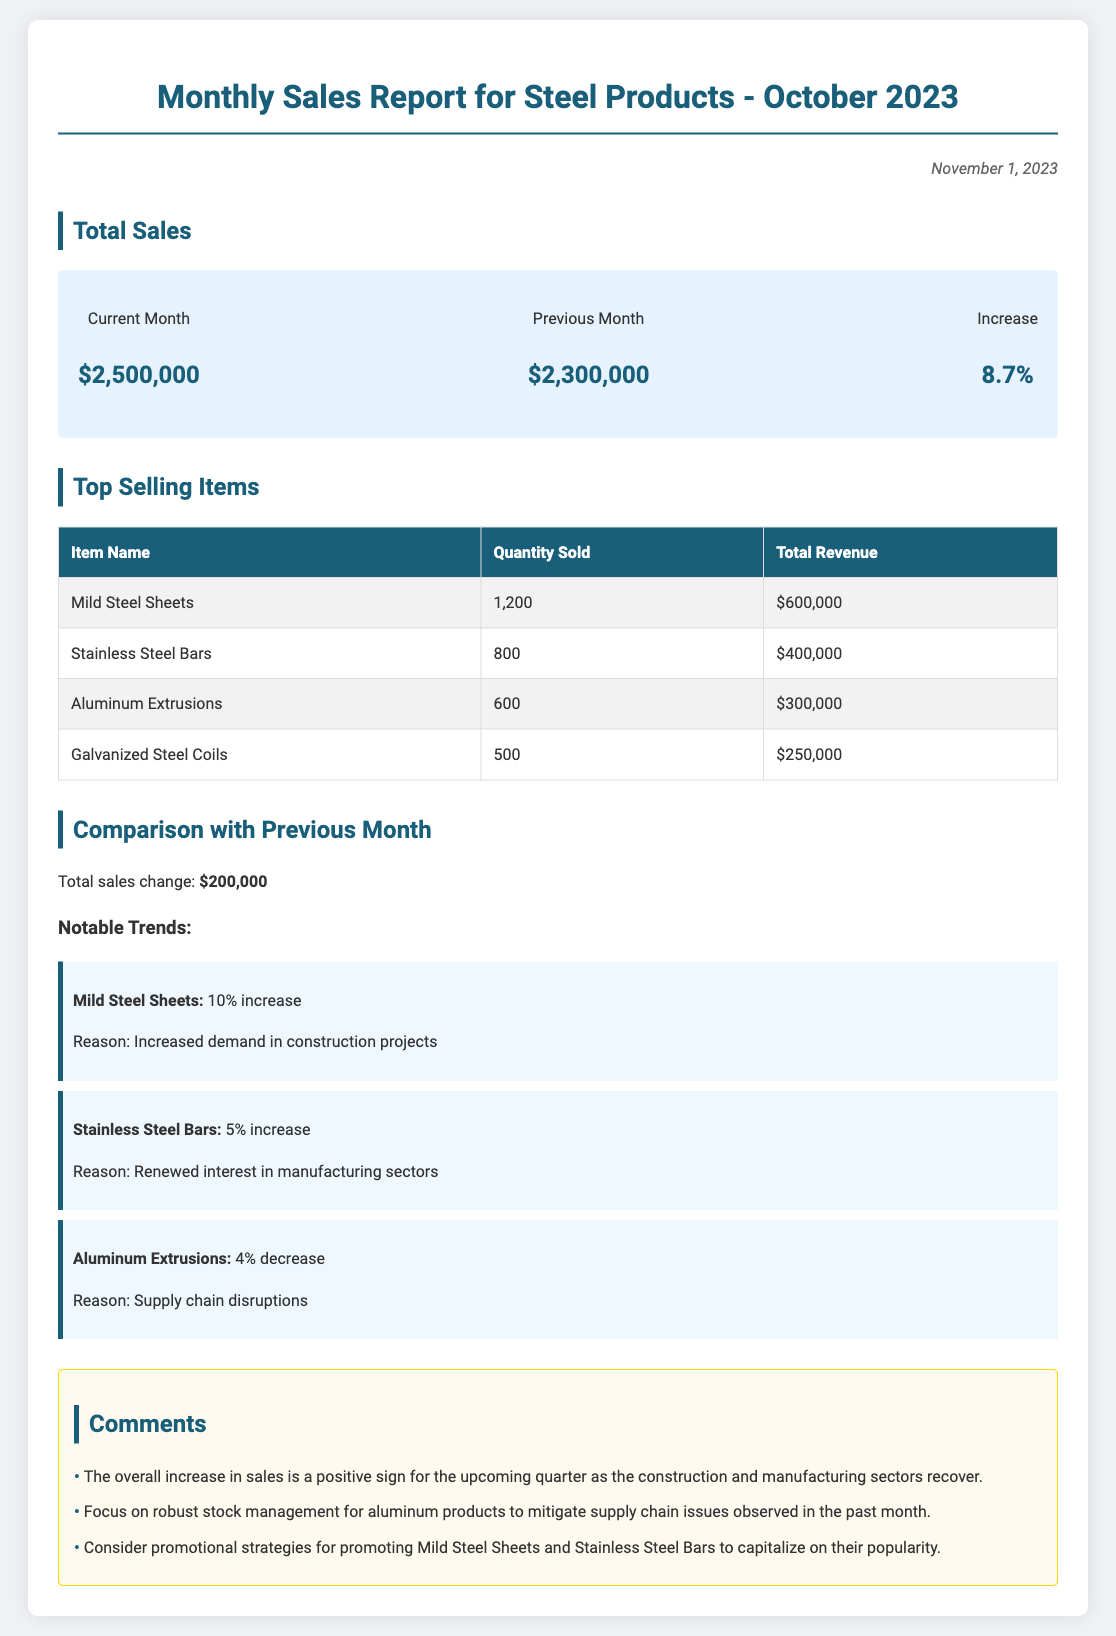What is the total sales for the current month? The total sales for the current month is stated in the document as $2,500,000.
Answer: $2,500,000 What was the total sales for the previous month? The document specifies that total sales for the previous month was $2,300,000.
Answer: $2,300,000 Which item was the top seller by quantity sold? The document indicates that Mild Steel Sheets had the highest quantity sold at 1,200 units.
Answer: Mild Steel Sheets What percentage increase in sales was observed compared to the previous month? The report highlights an increase of 8.7% in total sales compared to the previous month.
Answer: 8.7% What was the total revenue for Stainless Steel Bars? The document provides the total revenue for Stainless Steel Bars as $400,000.
Answer: $400,000 Which item experienced a decline in sales? The report identifies Aluminum Extrusions as having experienced a 4% decrease in sales.
Answer: Aluminum Extrusions What was the reason for the increase in sales of Mild Steel Sheets? The document states that the increase in sales is due to increased demand in construction projects.
Answer: Increased demand in construction projects How much total revenue did Galvanized Steel Coils generate? The revenue generated by Galvanized Steel Coils is noted in the document as $250,000.
Answer: $250,000 What was the notable trend for Stainless Steel Bars? The document mentions a 5% increase for Stainless Steel Bars as a notable trend.
Answer: 5% increase 